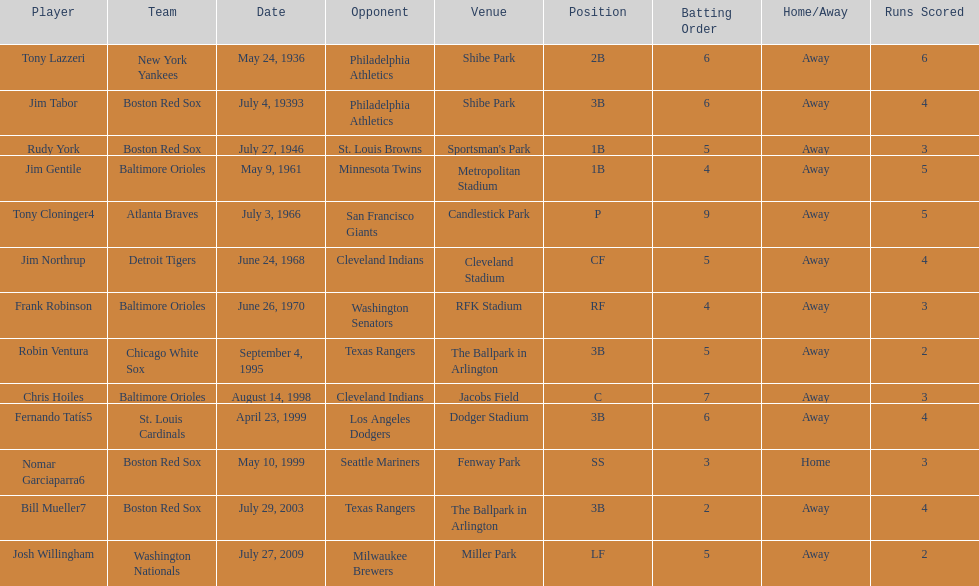On what date did the detroit tigers play the cleveland indians? June 24, 1968. 